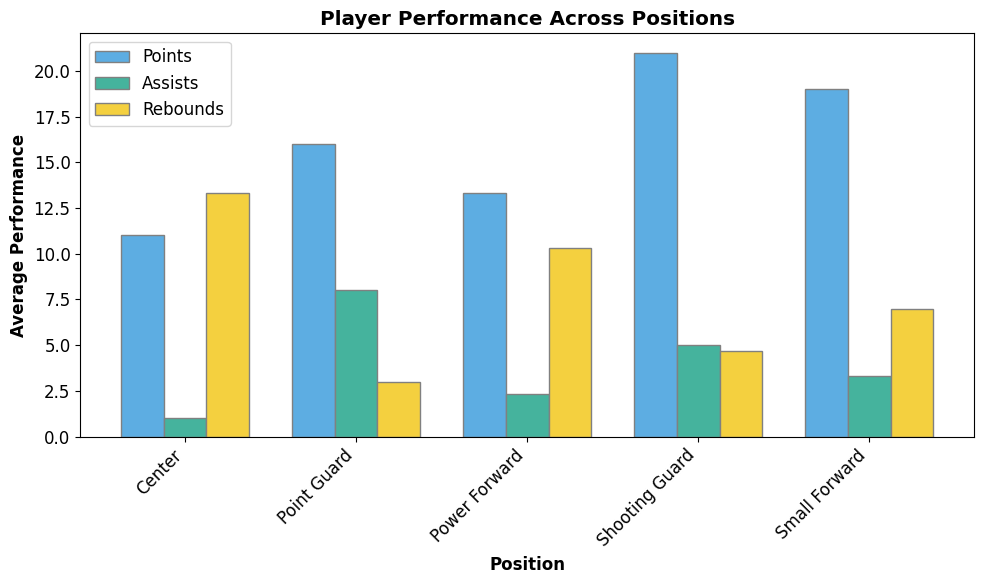What is the average performance in points for the Shooting Guard position? To find the average performance in points for the Shooting Guard position, look at the bars representing "Shooting Guard" for points and identify their heights. They are blue in color and located first in the series: 20, 22, and 21. The average is (20 + 22 + 21) / 3 = 21.
Answer: 21 Which position scored the highest average points? To determine which position scored the highest average points, compare the heights of the blue bars (representing points) for all positions. The "Shooting Guard" has the tallest blue bar.
Answer: Shooting Guard What is the difference in average rebounds between Power Forward and Center? Look at the yellow bars which represent rebounds. The average for "Power Forward" is 10.33 and for "Center" it is 13.33. The difference is 13.33 - 10.33 = 3.
Answer: 3 Which position has the lowest average assists? Identify the green bars which represent assists for all positions and compare their heights. The "Center" position has the shortest green bar, indicating the lowest average assists.
Answer: Center What is the total average performance in points across all positions? Sum up the average points for each position: Point Guard (16), Shooting Guard (21), Small Forward (19), Power Forward (13.33), Center (11). The total is 16 + 21 + 19 + 13.33 + 11 = 80.33.
Answer: 80.33 How many positions have an average rebounds greater than their average assists? Compare the yellow bars (rebounds) and green bars (assists) for each position. The positions where rebounds are greater than assists are "Small Forward", "Power Forward", and "Center", a total of 3 positions.
Answer: 3 Which color represents the assists in the bar plot? The assists bars are green in color.
Answer: Green For Point Guards, how much higher is the average points than the average assists? The average points for "Point Guard" is 16, and the average assists is 8. The difference is 16 - 8 = 8.
Answer: 8 Which position has the highest average in any of the three performance indicators (points, assists, rebounds)? Look at the tallest bar in each color category. "Shooting Guard" has the highest average points (21), which is the highest across all performance indicators.
Answer: Shooting Guard 